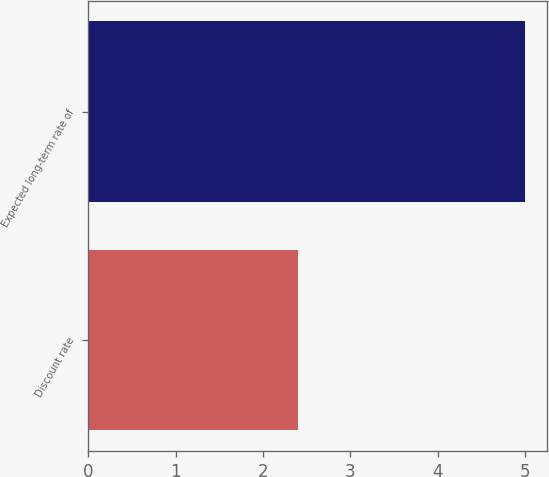Convert chart to OTSL. <chart><loc_0><loc_0><loc_500><loc_500><bar_chart><fcel>Discount rate<fcel>Expected long-term rate of<nl><fcel>2.4<fcel>5<nl></chart> 